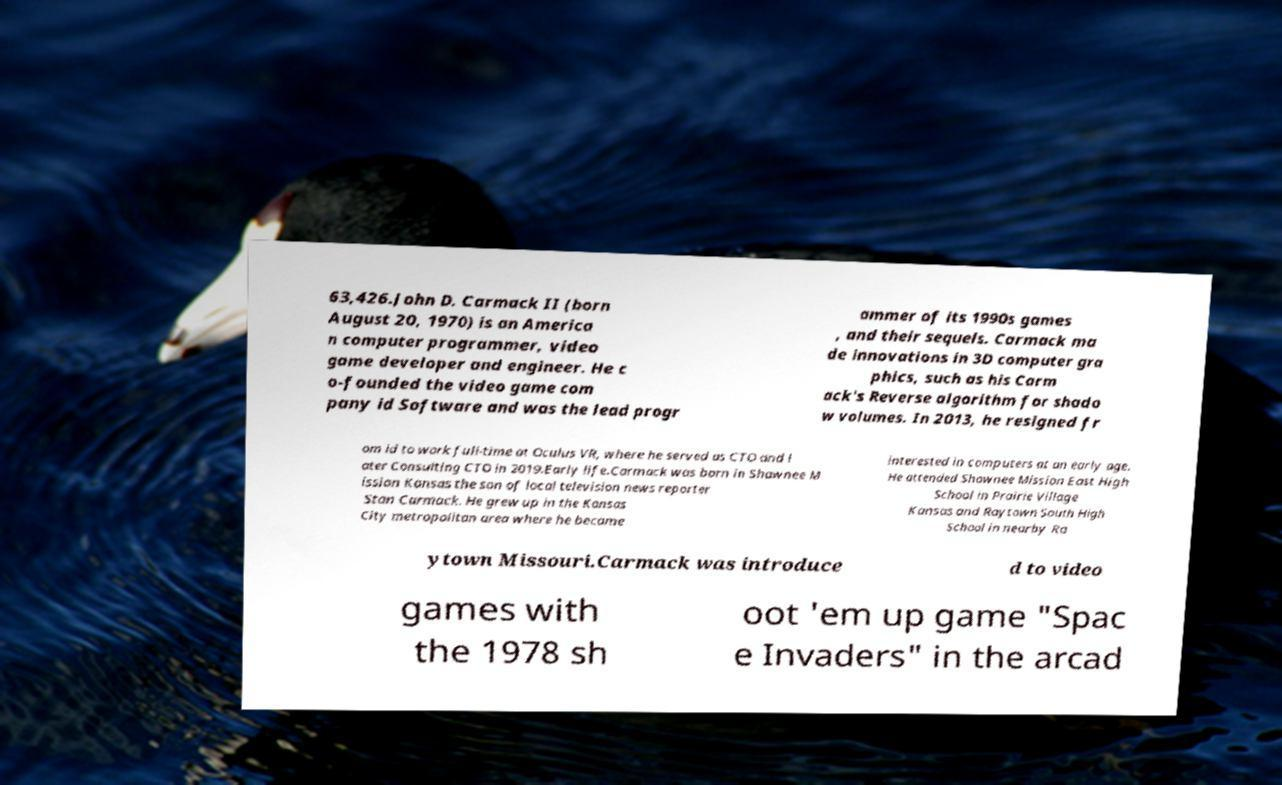Please read and relay the text visible in this image. What does it say? 63,426.John D. Carmack II (born August 20, 1970) is an America n computer programmer, video game developer and engineer. He c o-founded the video game com pany id Software and was the lead progr ammer of its 1990s games , and their sequels. Carmack ma de innovations in 3D computer gra phics, such as his Carm ack's Reverse algorithm for shado w volumes. In 2013, he resigned fr om id to work full-time at Oculus VR, where he served as CTO and l ater Consulting CTO in 2019.Early life.Carmack was born in Shawnee M ission Kansas the son of local television news reporter Stan Carmack. He grew up in the Kansas City metropolitan area where he became interested in computers at an early age. He attended Shawnee Mission East High School in Prairie Village Kansas and Raytown South High School in nearby Ra ytown Missouri.Carmack was introduce d to video games with the 1978 sh oot 'em up game "Spac e Invaders" in the arcad 